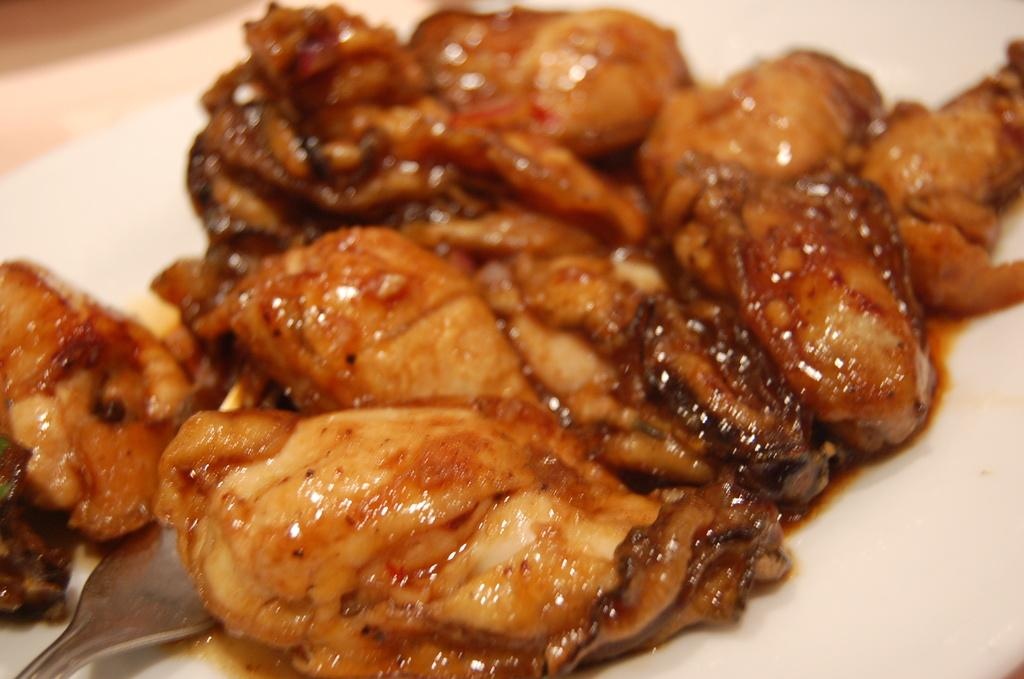What is the main subject of the image? The main subject of the image is food on a white surface. Can you describe the location of the spoon in the image? The spoon is in the left side bottom corner of the image. What type of cart is visible in the image? There is no cart present in the image. 